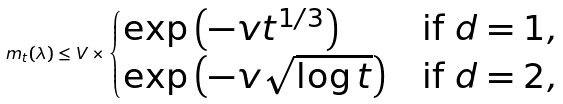<formula> <loc_0><loc_0><loc_500><loc_500>m _ { t } ( \lambda ) \leq V \times \begin{cases} \exp \left ( - v t ^ { 1 / 3 } \right ) & \text {if $d=1$} , \\ \exp \left ( - v \sqrt { \log t } \right ) & \text {if $d=2$} , \end{cases}</formula> 